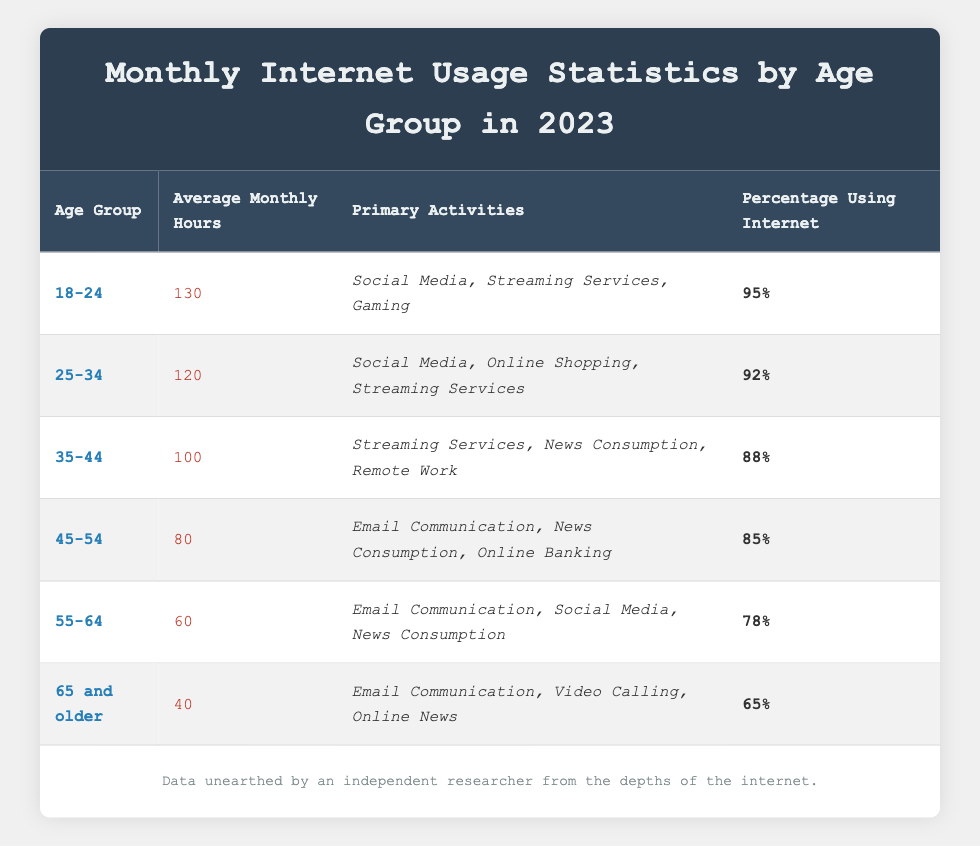What is the average monthly internet usage for the age group 25-34? From the table, the average monthly hours for the age group 25-34 is specified as 120 hours.
Answer: 120 Which age group has the highest percentage of internet usage? The age group 18-24 has the highest percentage of internet usage at 95%, as seen in the last column of the table.
Answer: 18-24 How many more average monthly hours does the 18-24 age group spend online compared to the 65 and older group? The average monthly hours for the 18-24 group is 130, while for the 65 and older group, it is 40. To find the difference: 130 - 40 = 90. Therefore, the 18-24 age group spends 90 more hours.
Answer: 90 Is the percentage of internet usage for the 55-64 age group greater than 80%? According to the table, the percentage of internet usage for the 55-64 age group is 78%, which is not greater than 80%. Therefore, the answer is no.
Answer: No What is the combined average monthly internet usage for the age groups 35-44 and 45-54? The average monthly hours for the 35-44 age group is 100 and for the 45-54 age group, it is 80. Combining these: 100 + 80 = 180. Therefore, the combined average monthly usage is 180 hours.
Answer: 180 Which primary activity is common to both the 25-34 and 55-64 age groups? Both age groups have "Social Media" listed as one of their primary activities. This is confirmed by looking at the primary activities for these age groups in the table.
Answer: Social Media How many total primary activities are listed across all age groups? The total number of unique primary activities can be calculated by listing them: Social Media, Streaming Services, Gaming, Online Shopping, News Consumption, Remote Work, Email Communication, Online Banking, and Video Calling. This gives a total of 9 unique activities.
Answer: 9 What is the average percentage of internet usage across all age groups? The percentages of internet usage for each age group are: 95, 92, 88, 85, 78, and 65. To calculate the average: (95 + 92 + 88 + 85 + 78 + 65) / 6 = 85.67, rounding gives an average of approximately 86%.
Answer: 86% 